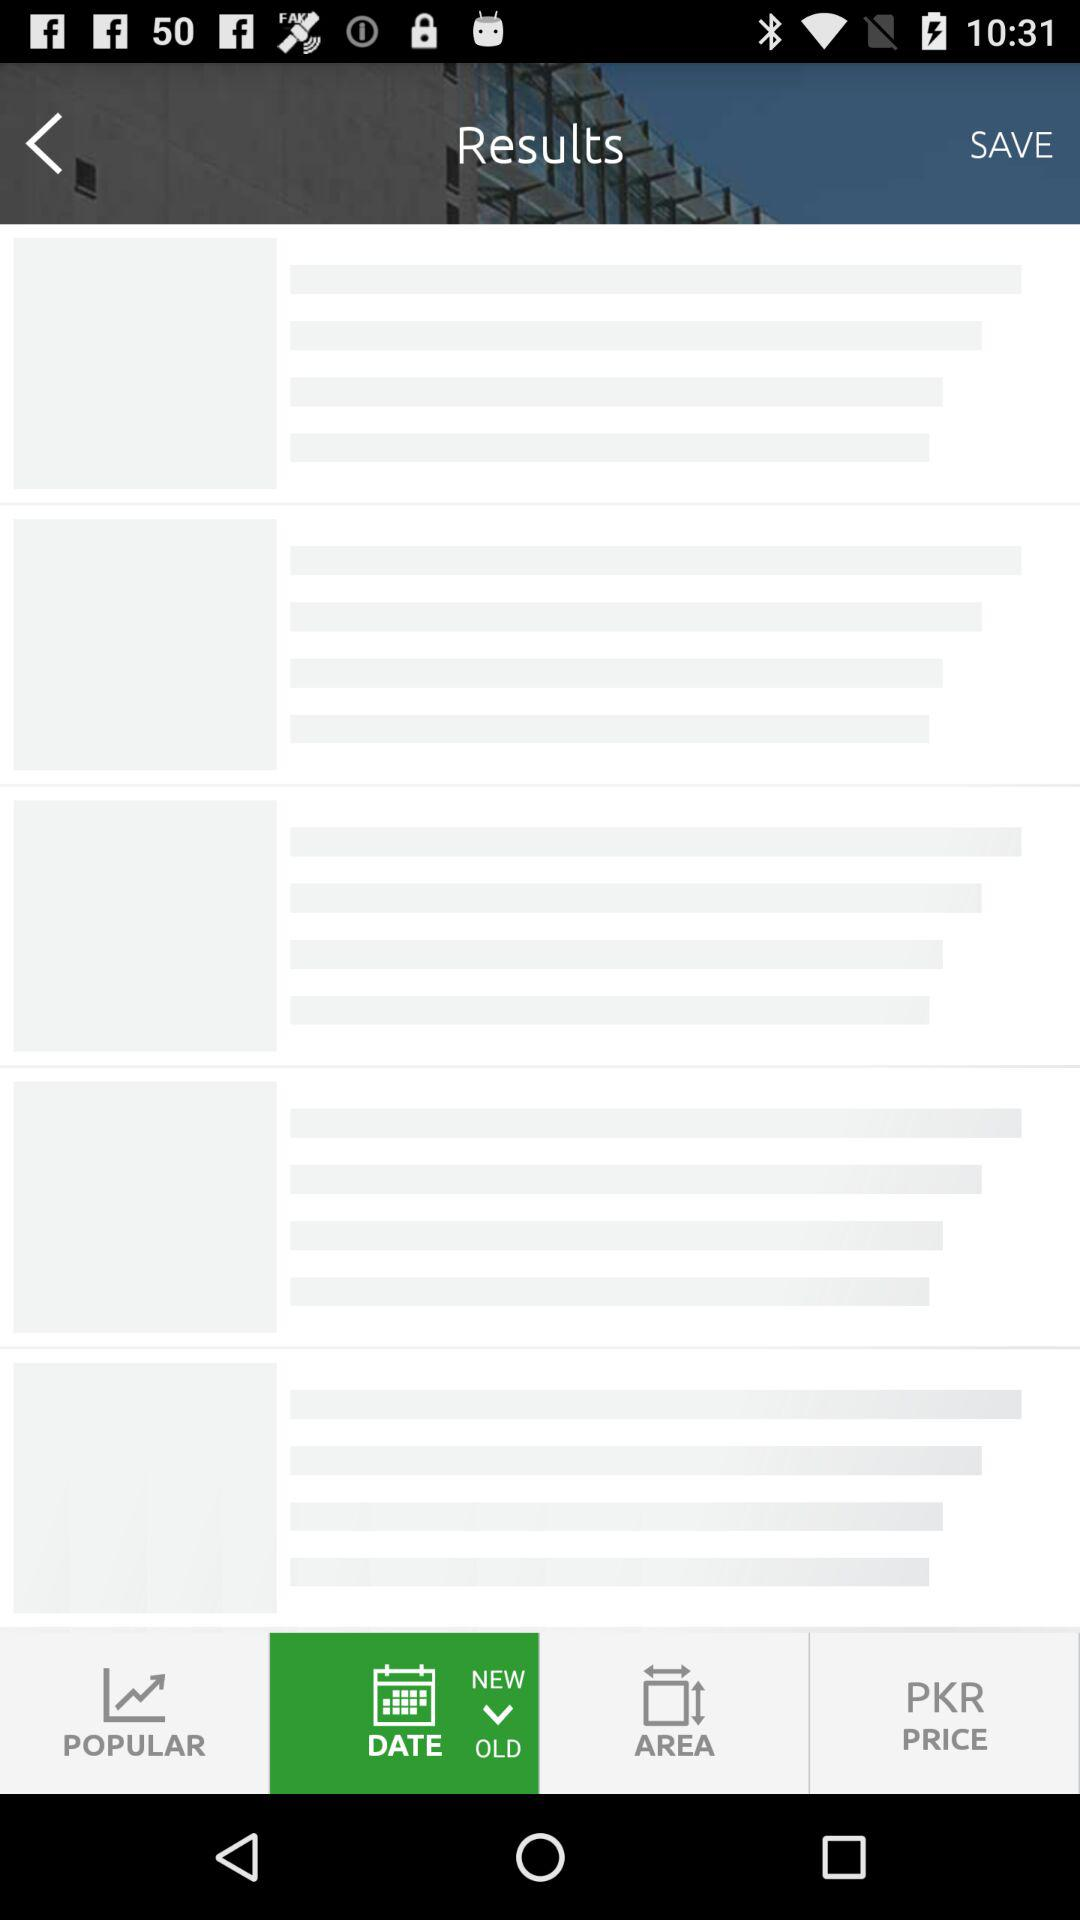What is the count of photos? The count of photos is 42. 